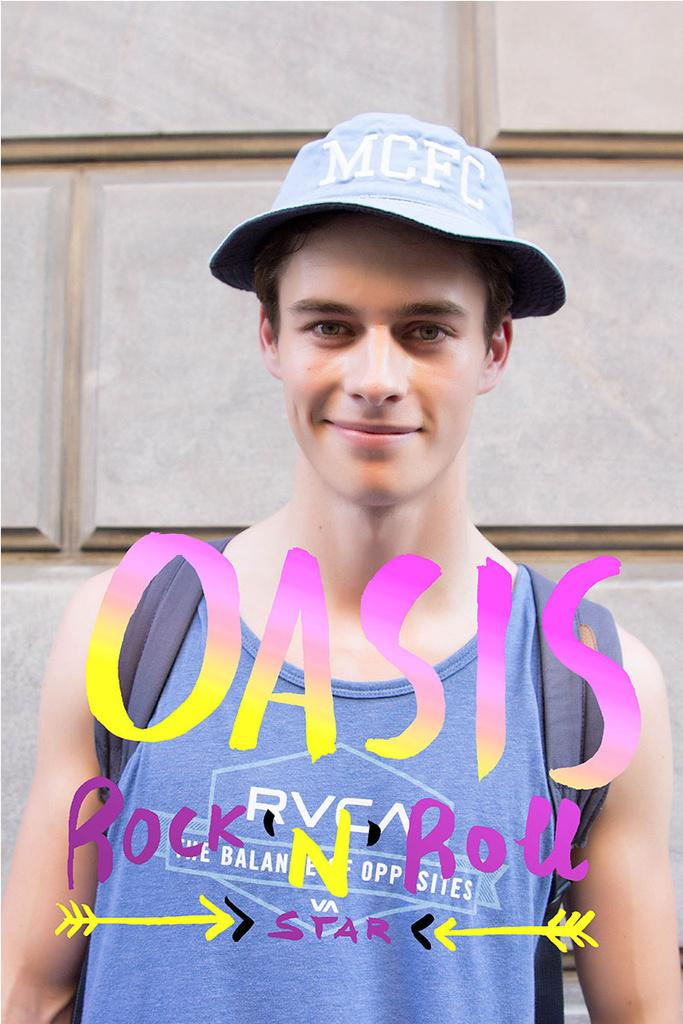What is the main subject of the image? The main subject of the image is a man. Can you describe the man's clothing in the image? The man is wearing a t-shirt and has a cap on his head. What is the man's facial expression in the image? The man is smiling in the image. What is the man doing in the image? The man is giving a pose for the picture. What can be seen in the background of the image? There is a wall in the background of the image. Are there any additional elements added to the image? Yes, there is edited text on the image. How does the man's secretary feel about his trip in the image? There is no mention of a trip or a secretary in the image, so it is not possible to determine how the secretary feels about the man's trip. 